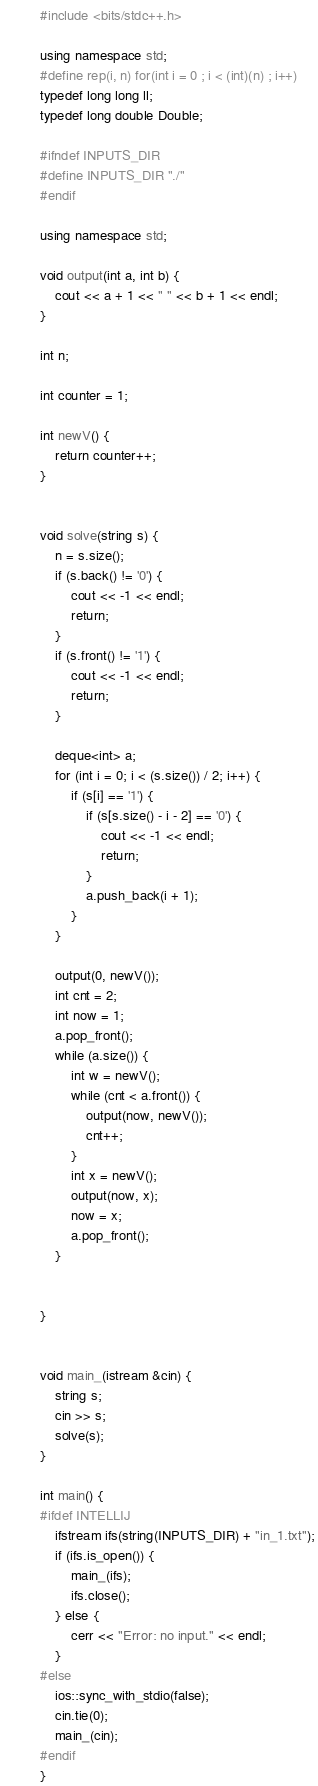Convert code to text. <code><loc_0><loc_0><loc_500><loc_500><_C++_>#include <bits/stdc++.h>

using namespace std;
#define rep(i, n) for(int i = 0 ; i < (int)(n) ; i++)
typedef long long ll;
typedef long double Double;

#ifndef INPUTS_DIR
#define INPUTS_DIR "./"
#endif

using namespace std;

void output(int a, int b) {
    cout << a + 1 << " " << b + 1 << endl;
}

int n;

int counter = 1;

int newV() {
    return counter++;
}


void solve(string s) {
    n = s.size();
    if (s.back() != '0') {
        cout << -1 << endl;
        return;
    }
    if (s.front() != '1') {
        cout << -1 << endl;
        return;
    }

    deque<int> a;
    for (int i = 0; i < (s.size()) / 2; i++) {
        if (s[i] == '1') {
            if (s[s.size() - i - 2] == '0') {
                cout << -1 << endl;
                return;
            }
            a.push_back(i + 1);
        }
    }

    output(0, newV());
    int cnt = 2;
    int now = 1;
    a.pop_front();
    while (a.size()) {
        int w = newV();
        while (cnt < a.front()) {
            output(now, newV());
            cnt++;
        }
        int x = newV();
        output(now, x);
        now = x;
        a.pop_front();
    }


}


void main_(istream &cin) {
    string s;
    cin >> s;
    solve(s);
}

int main() {
#ifdef INTELLIJ
    ifstream ifs(string(INPUTS_DIR) + "in_1.txt");
    if (ifs.is_open()) {
        main_(ifs);
        ifs.close();
    } else {
        cerr << "Error: no input." << endl;
    }
#else
    ios::sync_with_stdio(false);
    cin.tie(0);
    main_(cin);
#endif
}



</code> 